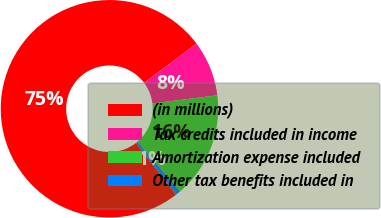Convert chart. <chart><loc_0><loc_0><loc_500><loc_500><pie_chart><fcel>(in millions)<fcel>Tax credits included in income<fcel>Amortization expense included<fcel>Other tax benefits included in<nl><fcel>75.29%<fcel>8.24%<fcel>15.69%<fcel>0.78%<nl></chart> 